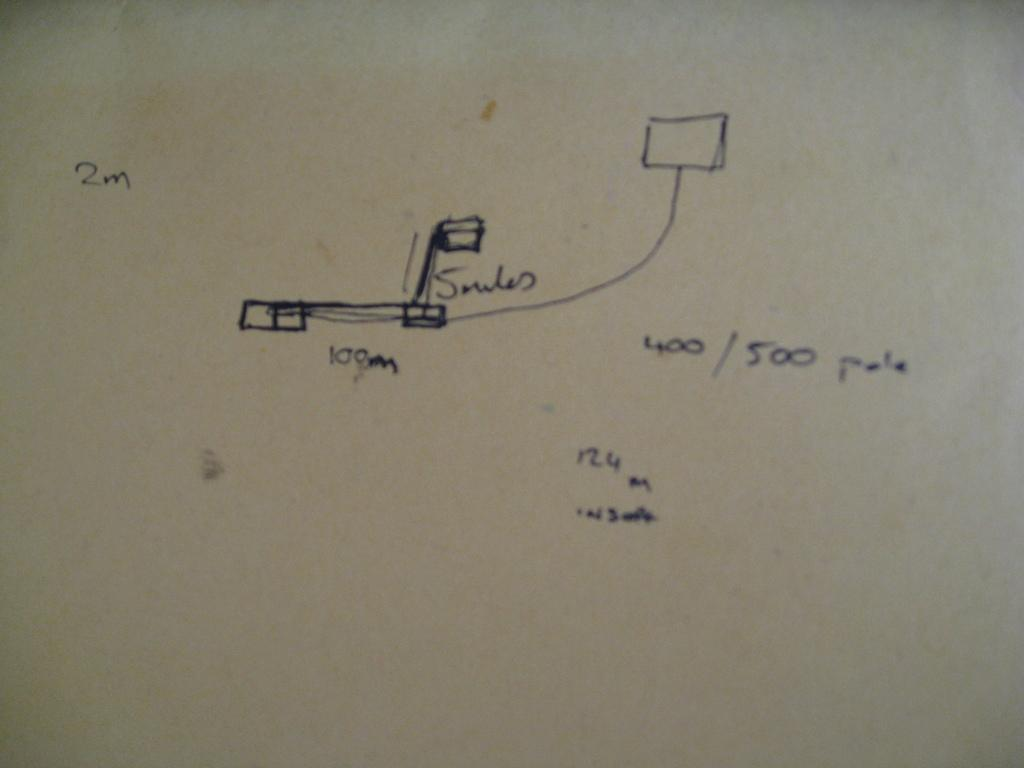<image>
Summarize the visual content of the image. a diagram on some paper with 2m visible to the top left. 